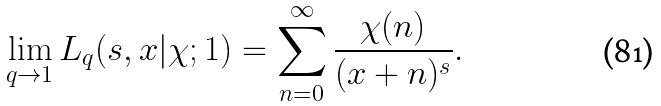Convert formula to latex. <formula><loc_0><loc_0><loc_500><loc_500>\lim _ { q \rightarrow 1 } L _ { q } ( s , x | \chi ; 1 ) = \sum _ { n = 0 } ^ { \infty } \frac { \chi ( n ) } { ( x + n ) ^ { s } } .</formula> 